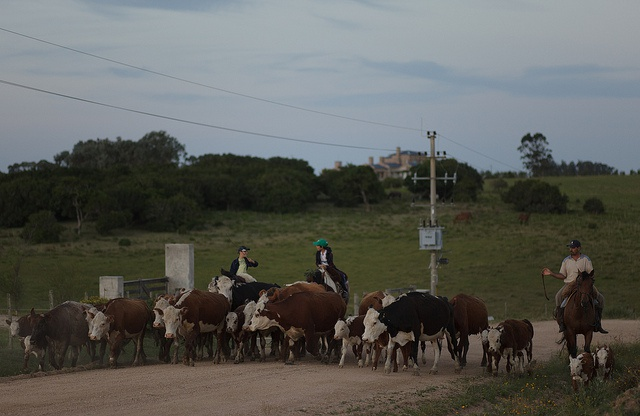Describe the objects in this image and their specific colors. I can see cow in darkgray, black, and gray tones, cow in darkgray, black, and gray tones, cow in darkgray, black, gray, and maroon tones, cow in darkgray, black, and gray tones, and cow in darkgray, black, and gray tones in this image. 